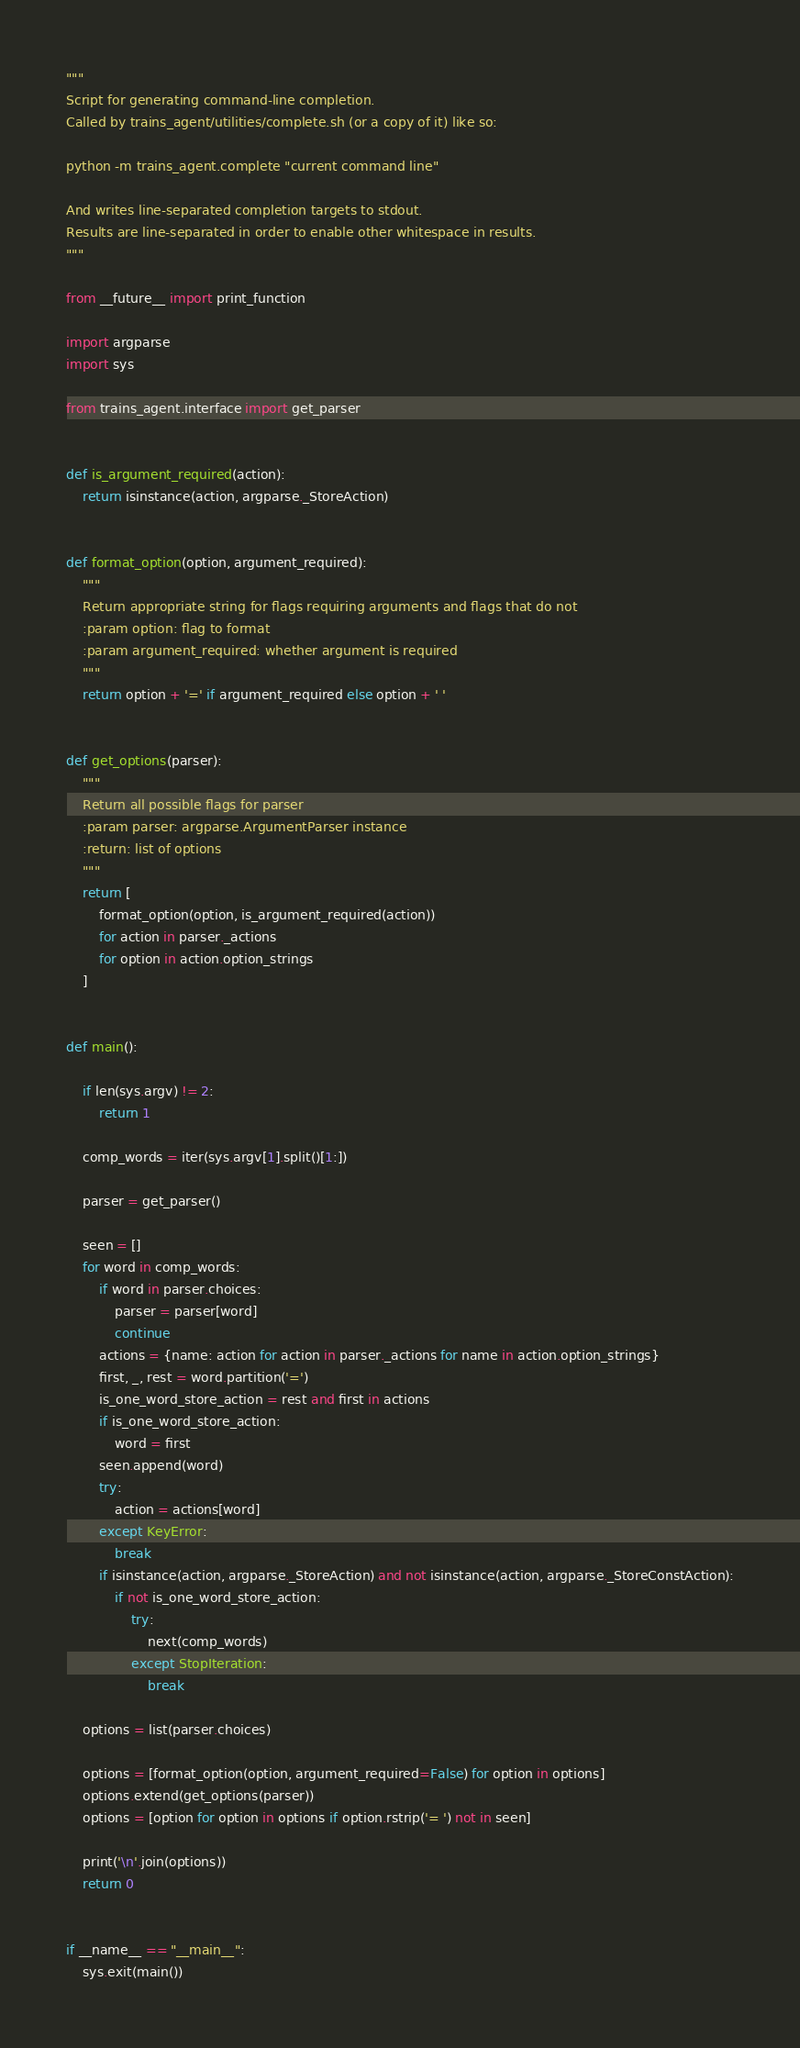<code> <loc_0><loc_0><loc_500><loc_500><_Python_>"""
Script for generating command-line completion.
Called by trains_agent/utilities/complete.sh (or a copy of it) like so:

python -m trains_agent.complete "current command line"

And writes line-separated completion targets to stdout.
Results are line-separated in order to enable other whitespace in results.
"""

from __future__ import print_function

import argparse
import sys

from trains_agent.interface import get_parser


def is_argument_required(action):
    return isinstance(action, argparse._StoreAction)


def format_option(option, argument_required):
    """
    Return appropriate string for flags requiring arguments and flags that do not
    :param option: flag to format
    :param argument_required: whether argument is required
    """
    return option + '=' if argument_required else option + ' '


def get_options(parser):
    """
    Return all possible flags for parser
    :param parser: argparse.ArgumentParser instance
    :return: list of options
    """
    return [
        format_option(option, is_argument_required(action))
        for action in parser._actions
        for option in action.option_strings
    ]


def main():

    if len(sys.argv) != 2:
        return 1

    comp_words = iter(sys.argv[1].split()[1:])

    parser = get_parser()

    seen = []
    for word in comp_words:
        if word in parser.choices:
            parser = parser[word]
            continue
        actions = {name: action for action in parser._actions for name in action.option_strings}
        first, _, rest = word.partition('=')
        is_one_word_store_action = rest and first in actions
        if is_one_word_store_action:
            word = first
        seen.append(word)
        try:
            action = actions[word]
        except KeyError:
            break
        if isinstance(action, argparse._StoreAction) and not isinstance(action, argparse._StoreConstAction):
            if not is_one_word_store_action:
                try:
                    next(comp_words)
                except StopIteration:
                    break

    options = list(parser.choices)

    options = [format_option(option, argument_required=False) for option in options]
    options.extend(get_options(parser))
    options = [option for option in options if option.rstrip('= ') not in seen]

    print('\n'.join(options))
    return 0


if __name__ == "__main__":
    sys.exit(main())
</code> 